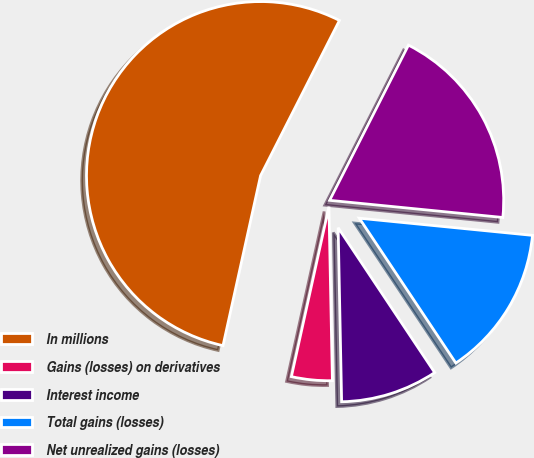Convert chart to OTSL. <chart><loc_0><loc_0><loc_500><loc_500><pie_chart><fcel>In millions<fcel>Gains (losses) on derivatives<fcel>Interest income<fcel>Total gains (losses)<fcel>Net unrealized gains (losses)<nl><fcel>54.02%<fcel>3.78%<fcel>9.04%<fcel>14.07%<fcel>19.09%<nl></chart> 